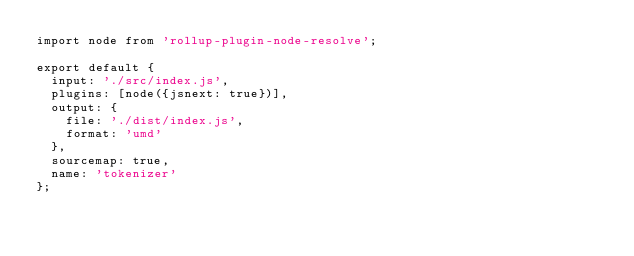Convert code to text. <code><loc_0><loc_0><loc_500><loc_500><_JavaScript_>import node from 'rollup-plugin-node-resolve';

export default {
  input: './src/index.js',
  plugins: [node({jsnext: true})],
  output: {
    file: './dist/index.js',
    format: 'umd'
  },
  sourcemap: true,
  name: 'tokenizer'
};</code> 